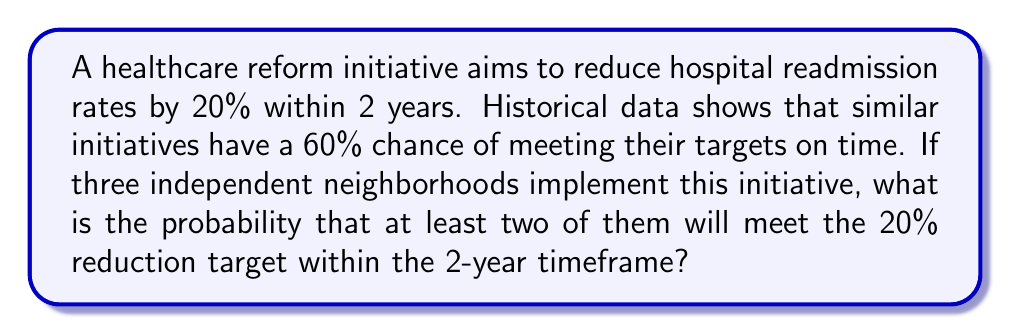Give your solution to this math problem. Let's approach this step-by-step:

1) First, we need to identify the probability distribution. This scenario follows a binomial distribution, where each neighborhood has two possible outcomes (success or failure) with a fixed probability.

2) Let $p$ be the probability of success for a single neighborhood. We're given that $p = 0.60$ or 60%.

3) We want the probability of at least 2 out of 3 neighborhoods succeeding. This can be calculated as:
   $P(\text{at least 2 successes}) = P(2 \text{ successes}) + P(3 \text{ successes})$

4) For a binomial distribution, the probability of exactly $k$ successes in $n$ trials is given by:
   $P(X = k) = \binom{n}{k} p^k (1-p)^{n-k}$

5) Let's calculate each part:
   
   For 2 successes: $P(X = 2) = \binom{3}{2} (0.60)^2 (0.40)^1$
   $$ = 3 \cdot 0.36 \cdot 0.40 = 0.432 $$

   For 3 successes: $P(X = 3) = \binom{3}{3} (0.60)^3 (0.40)^0$
   $$ = 1 \cdot 0.216 \cdot 1 = 0.216 $$

6) Now, we sum these probabilities:
   $P(\text{at least 2 successes}) = 0.432 + 0.216 = 0.648$

Therefore, the probability of at least two neighborhoods meeting the target is 0.648 or 64.8%.
Answer: 0.648 